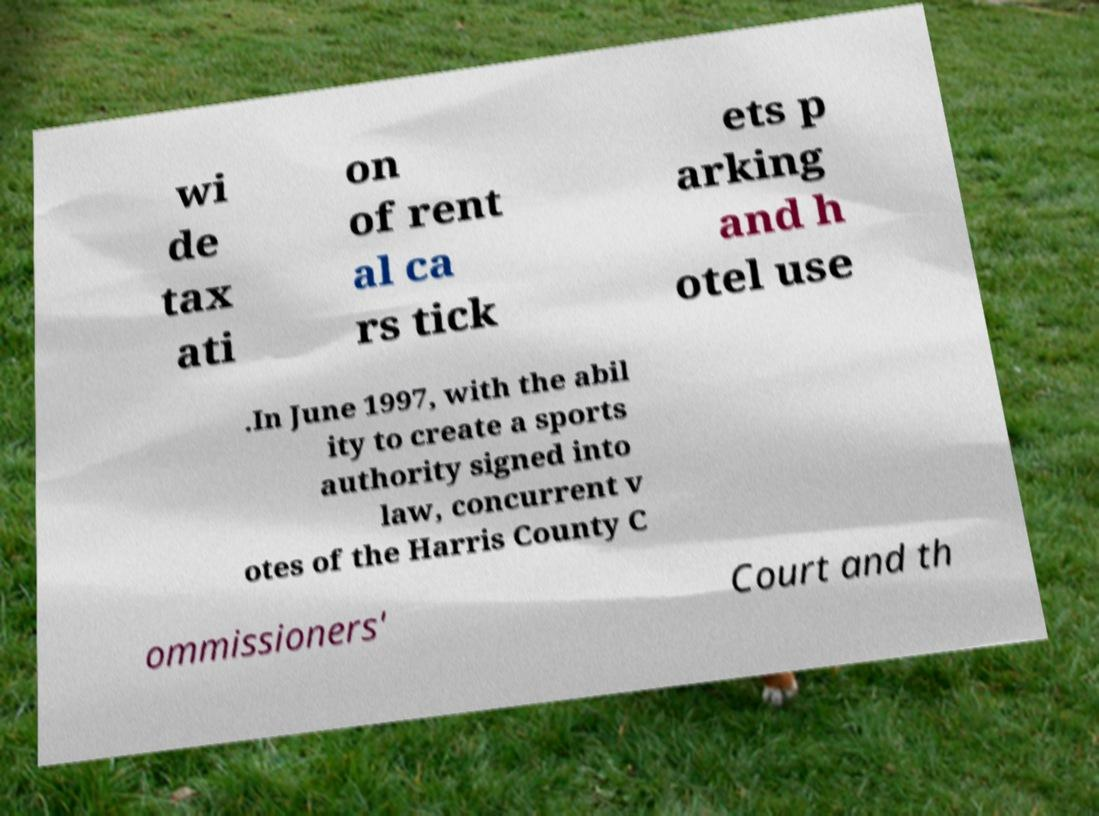I need the written content from this picture converted into text. Can you do that? wi de tax ati on of rent al ca rs tick ets p arking and h otel use .In June 1997, with the abil ity to create a sports authority signed into law, concurrent v otes of the Harris County C ommissioners' Court and th 